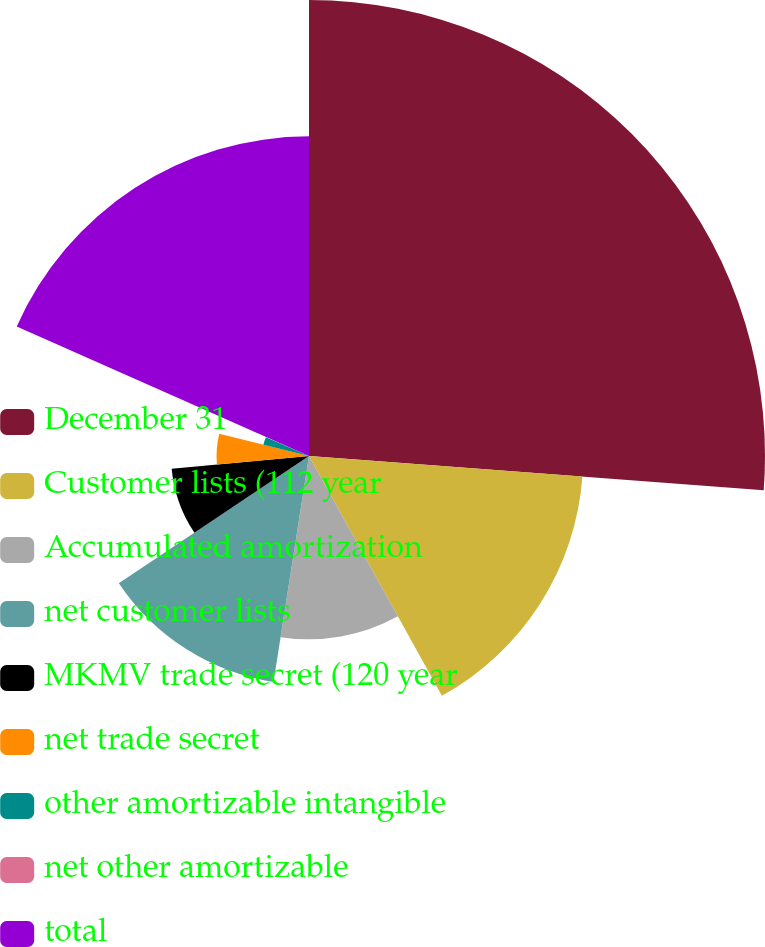Convert chart to OTSL. <chart><loc_0><loc_0><loc_500><loc_500><pie_chart><fcel>December 31<fcel>Customer lists (112 year<fcel>Accumulated amortization<fcel>net customer lists<fcel>MKMV trade secret (120 year<fcel>net trade secret<fcel>other amortizable intangible<fcel>net other amortizable<fcel>total<nl><fcel>26.19%<fcel>15.75%<fcel>10.53%<fcel>13.14%<fcel>7.92%<fcel>5.31%<fcel>2.7%<fcel>0.09%<fcel>18.36%<nl></chart> 